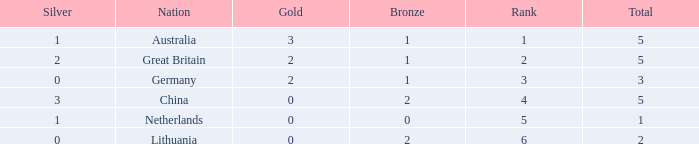What is the average for silver when bronze is less than 1, and gold is more than 0? None. Could you parse the entire table? {'header': ['Silver', 'Nation', 'Gold', 'Bronze', 'Rank', 'Total'], 'rows': [['1', 'Australia', '3', '1', '1', '5'], ['2', 'Great Britain', '2', '1', '2', '5'], ['0', 'Germany', '2', '1', '3', '3'], ['3', 'China', '0', '2', '4', '5'], ['1', 'Netherlands', '0', '0', '5', '1'], ['0', 'Lithuania', '0', '2', '6', '2']]} 